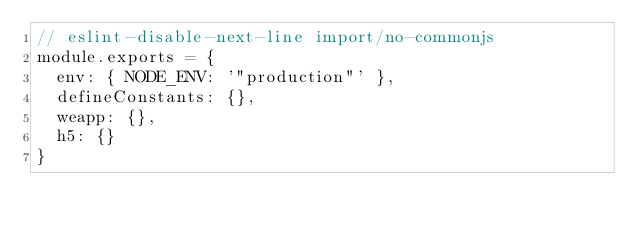<code> <loc_0><loc_0><loc_500><loc_500><_JavaScript_>// eslint-disable-next-line import/no-commonjs
module.exports = {
  env: { NODE_ENV: '"production"' },
  defineConstants: {},
  weapp: {},
  h5: {}
}
</code> 